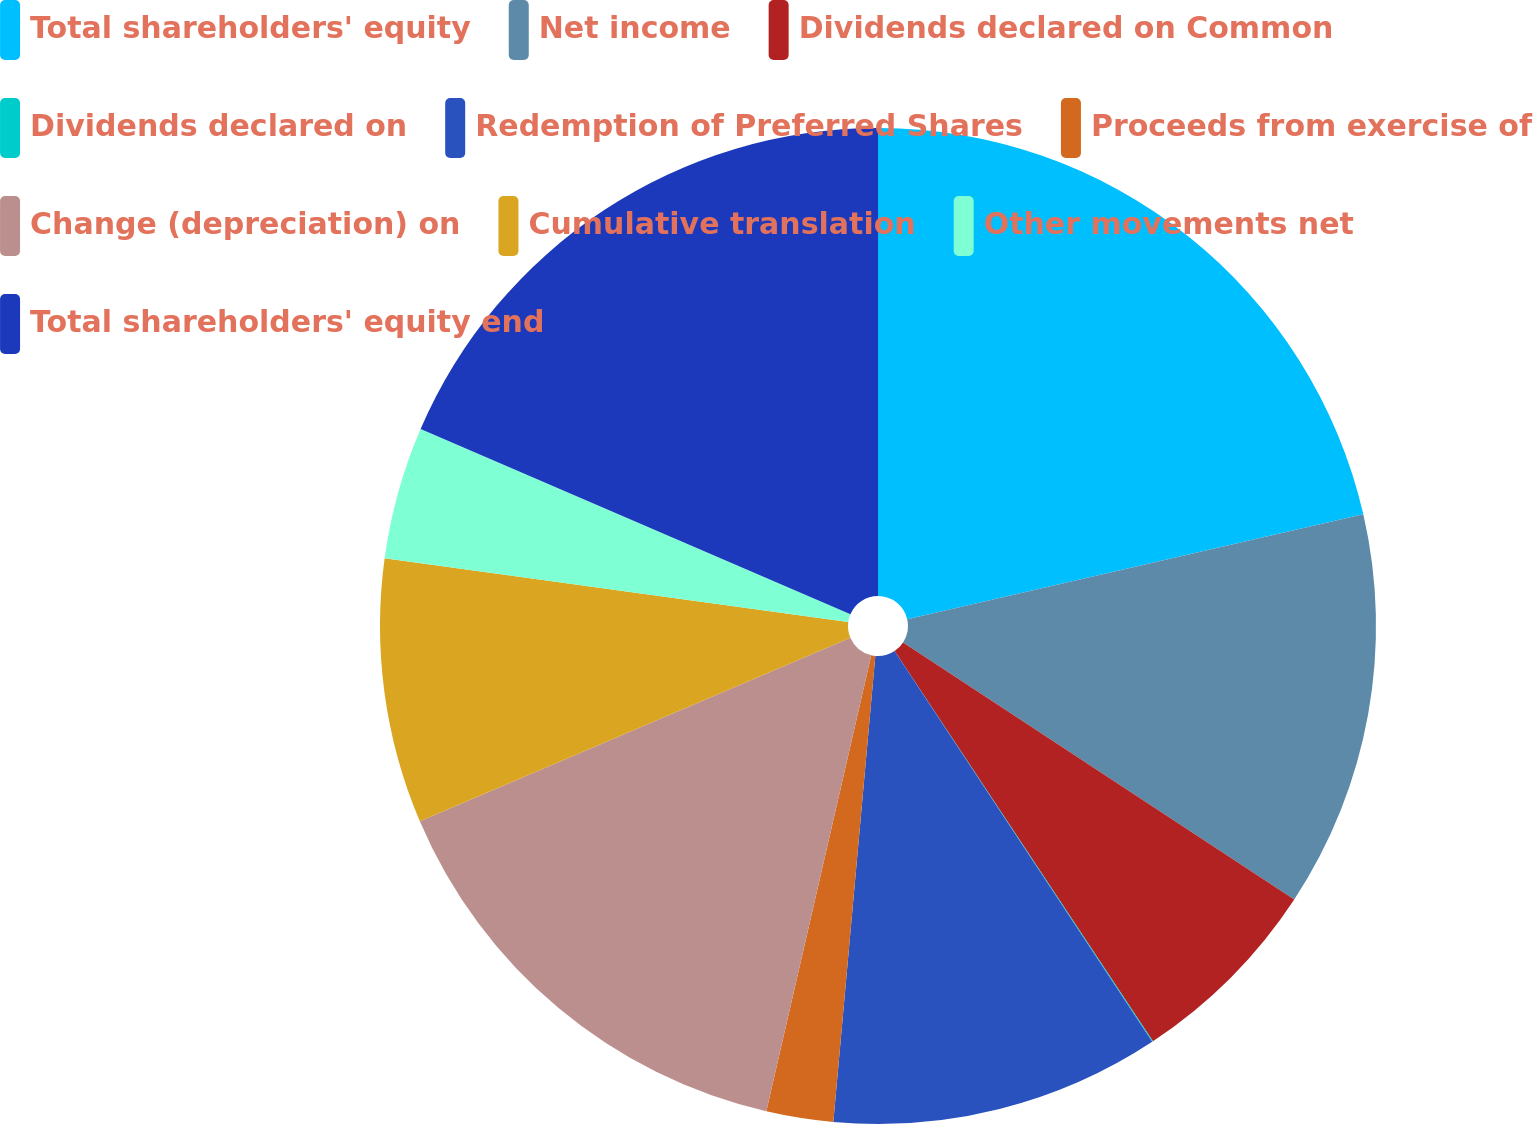Convert chart. <chart><loc_0><loc_0><loc_500><loc_500><pie_chart><fcel>Total shareholders' equity<fcel>Net income<fcel>Dividends declared on Common<fcel>Dividends declared on<fcel>Redemption of Preferred Shares<fcel>Proceeds from exercise of<fcel>Change (depreciation) on<fcel>Cumulative translation<fcel>Other movements net<fcel>Total shareholders' equity end<nl><fcel>21.4%<fcel>12.85%<fcel>6.44%<fcel>0.03%<fcel>10.71%<fcel>2.17%<fcel>14.99%<fcel>8.58%<fcel>4.3%<fcel>18.53%<nl></chart> 